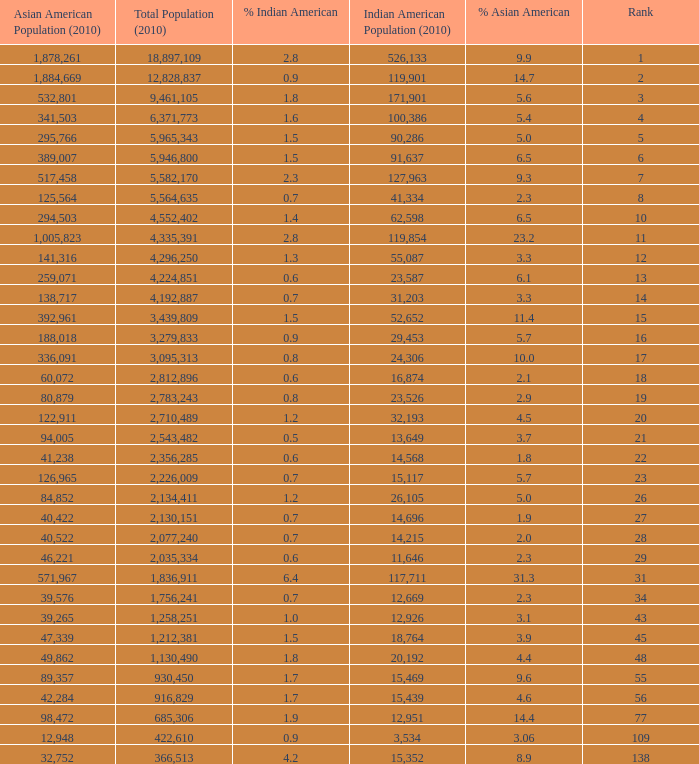What's the total population when there are 5.7% Asian American and fewer than 126,965 Asian American Population? None. 